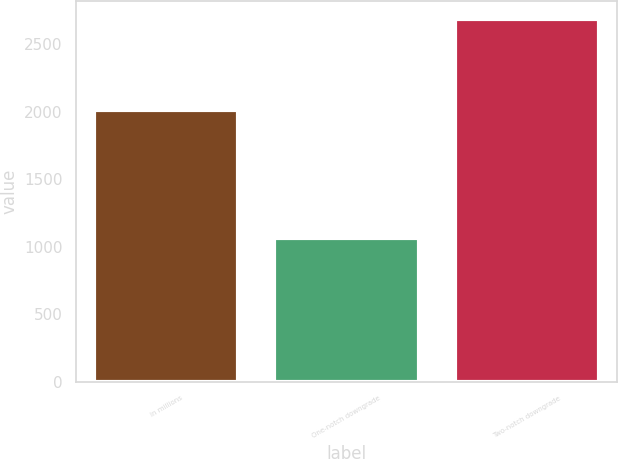<chart> <loc_0><loc_0><loc_500><loc_500><bar_chart><fcel>in millions<fcel>One-notch downgrade<fcel>Two-notch downgrade<nl><fcel>2015<fcel>1061<fcel>2689<nl></chart> 